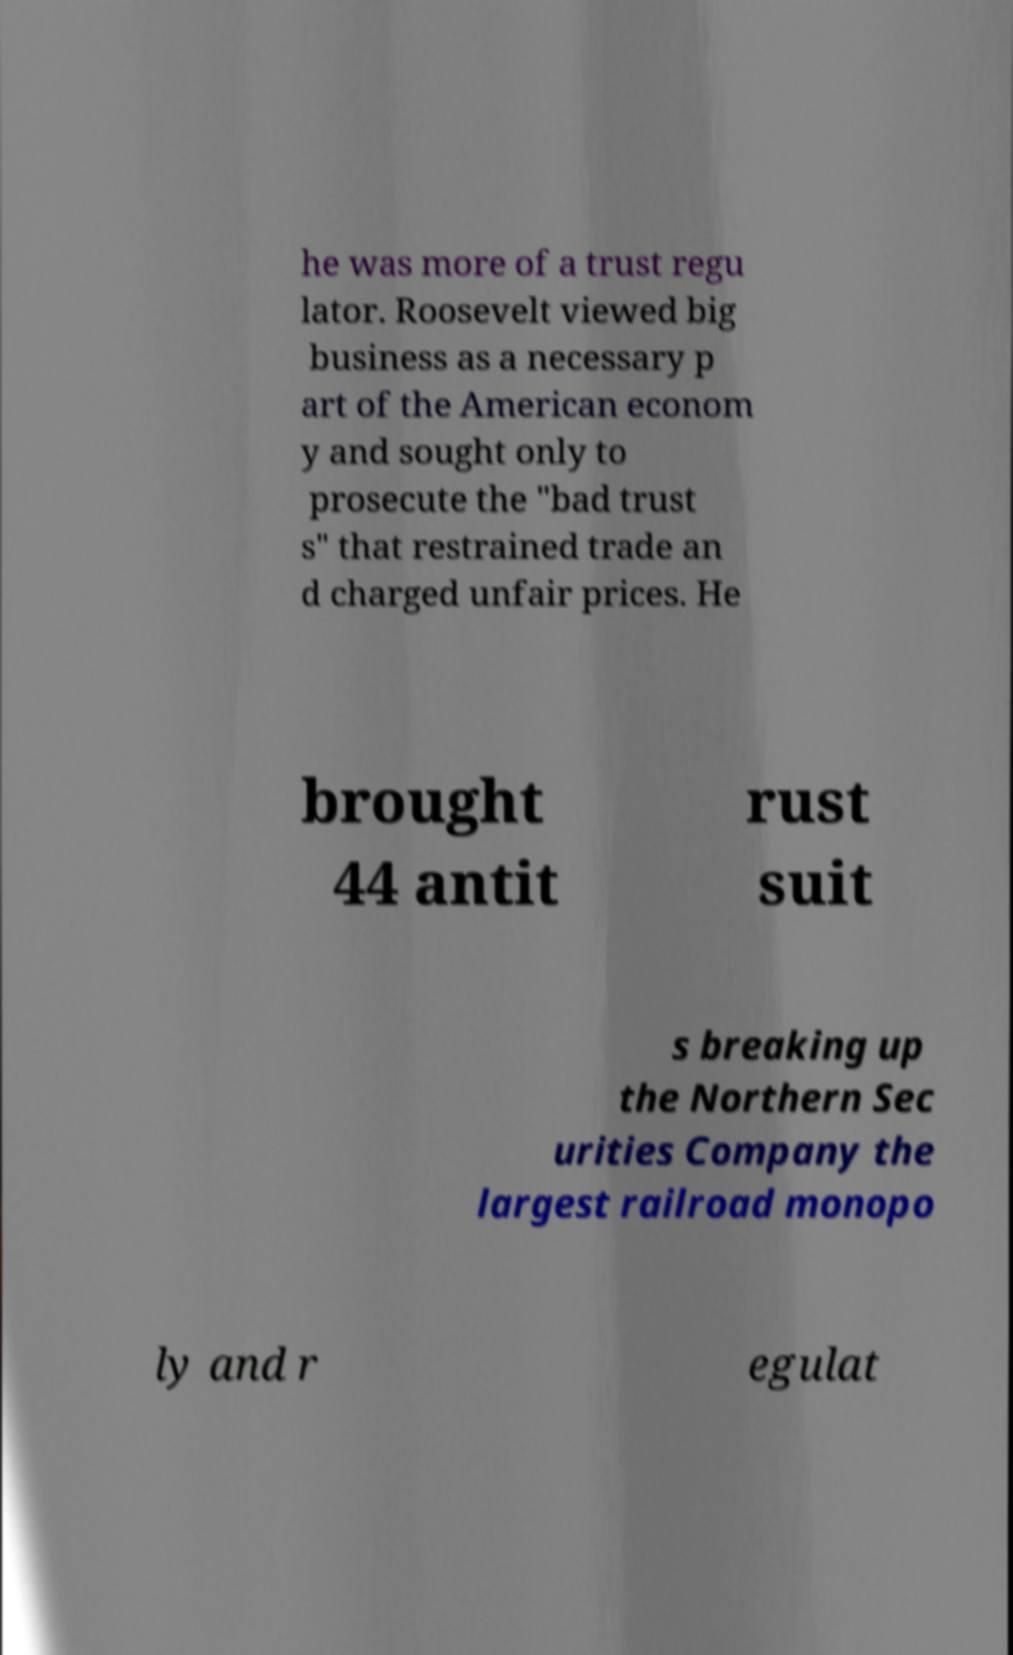Could you extract and type out the text from this image? he was more of a trust regu lator. Roosevelt viewed big business as a necessary p art of the American econom y and sought only to prosecute the "bad trust s" that restrained trade an d charged unfair prices. He brought 44 antit rust suit s breaking up the Northern Sec urities Company the largest railroad monopo ly and r egulat 